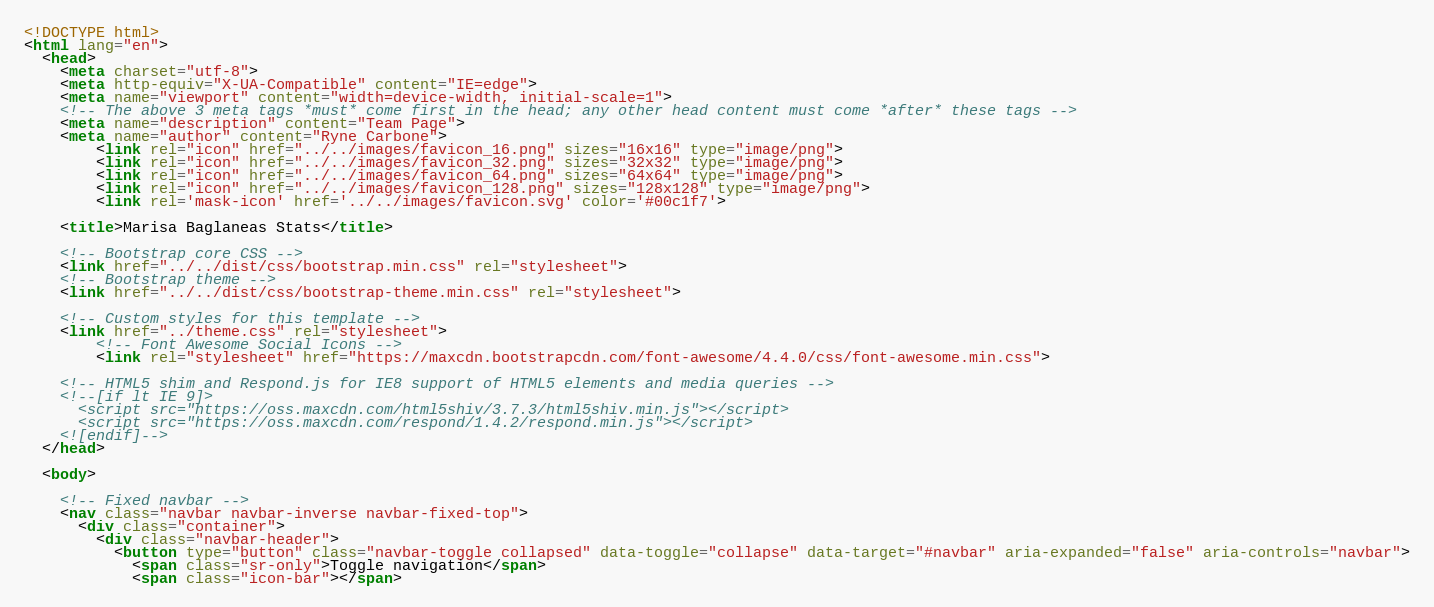<code> <loc_0><loc_0><loc_500><loc_500><_HTML_><!DOCTYPE html>
<html lang="en">
  <head>
    <meta charset="utf-8">
    <meta http-equiv="X-UA-Compatible" content="IE=edge">
    <meta name="viewport" content="width=device-width, initial-scale=1">
    <!-- The above 3 meta tags *must* come first in the head; any other head content must come *after* these tags -->
    <meta name="description" content="Team Page">
    <meta name="author" content="Ryne Carbone">
		<link rel="icon" href="../../images/favicon_16.png" sizes="16x16" type="image/png">
		<link rel="icon" href="../../images/favicon_32.png" sizes="32x32" type="image/png">
		<link rel="icon" href="../../images/favicon_64.png" sizes="64x64" type="image/png">
		<link rel="icon" href="../../images/favicon_128.png" sizes="128x128" type="image/png">
		<link rel='mask-icon' href='../../images/favicon.svg' color='#00c1f7'>

    <title>Marisa Baglaneas Stats</title>

    <!-- Bootstrap core CSS -->
    <link href="../../dist/css/bootstrap.min.css" rel="stylesheet">
    <!-- Bootstrap theme -->
    <link href="../../dist/css/bootstrap-theme.min.css" rel="stylesheet">

    <!-- Custom styles for this template -->
    <link href="../theme.css" rel="stylesheet">
		<!-- Font Awesome Social Icons -->
		<link rel="stylesheet" href="https://maxcdn.bootstrapcdn.com/font-awesome/4.4.0/css/font-awesome.min.css">

    <!-- HTML5 shim and Respond.js for IE8 support of HTML5 elements and media queries -->
    <!--[if lt IE 9]>
      <script src="https://oss.maxcdn.com/html5shiv/3.7.3/html5shiv.min.js"></script>
      <script src="https://oss.maxcdn.com/respond/1.4.2/respond.min.js"></script>
    <![endif]-->
  </head>

  <body>

    <!-- Fixed navbar -->
    <nav class="navbar navbar-inverse navbar-fixed-top">
      <div class="container">
        <div class="navbar-header">
          <button type="button" class="navbar-toggle collapsed" data-toggle="collapse" data-target="#navbar" aria-expanded="false" aria-controls="navbar">
            <span class="sr-only">Toggle navigation</span>
            <span class="icon-bar"></span></code> 